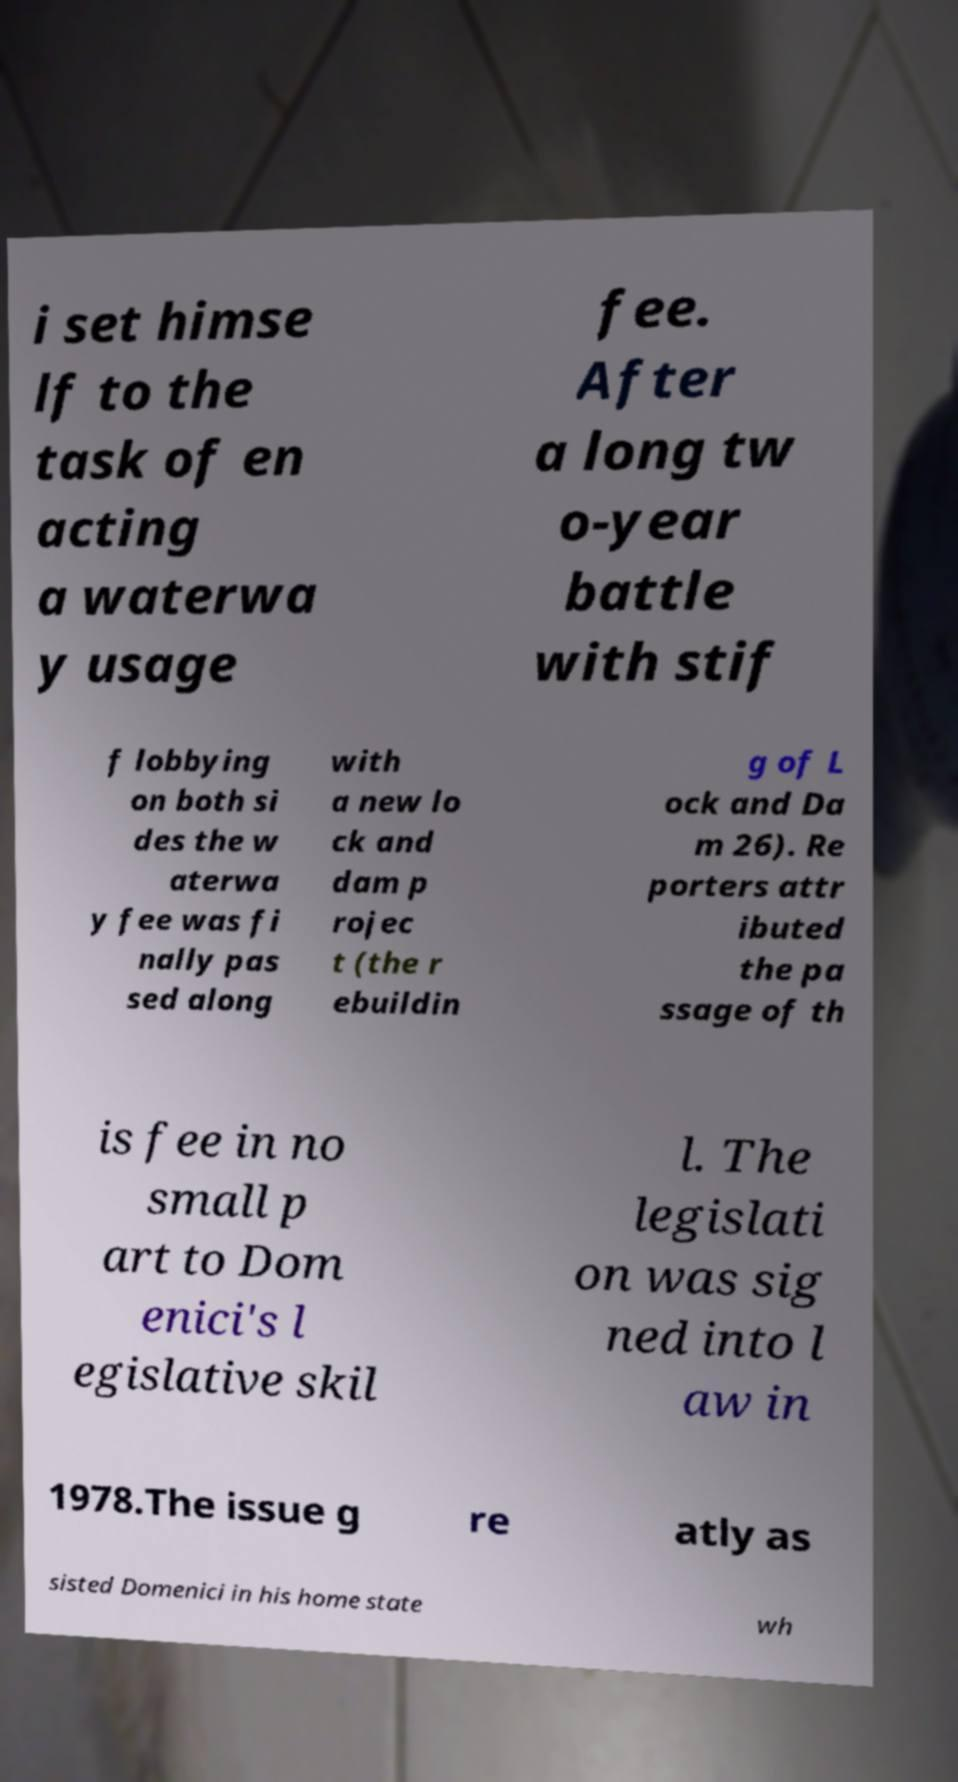For documentation purposes, I need the text within this image transcribed. Could you provide that? i set himse lf to the task of en acting a waterwa y usage fee. After a long tw o-year battle with stif f lobbying on both si des the w aterwa y fee was fi nally pas sed along with a new lo ck and dam p rojec t (the r ebuildin g of L ock and Da m 26). Re porters attr ibuted the pa ssage of th is fee in no small p art to Dom enici's l egislative skil l. The legislati on was sig ned into l aw in 1978.The issue g re atly as sisted Domenici in his home state wh 